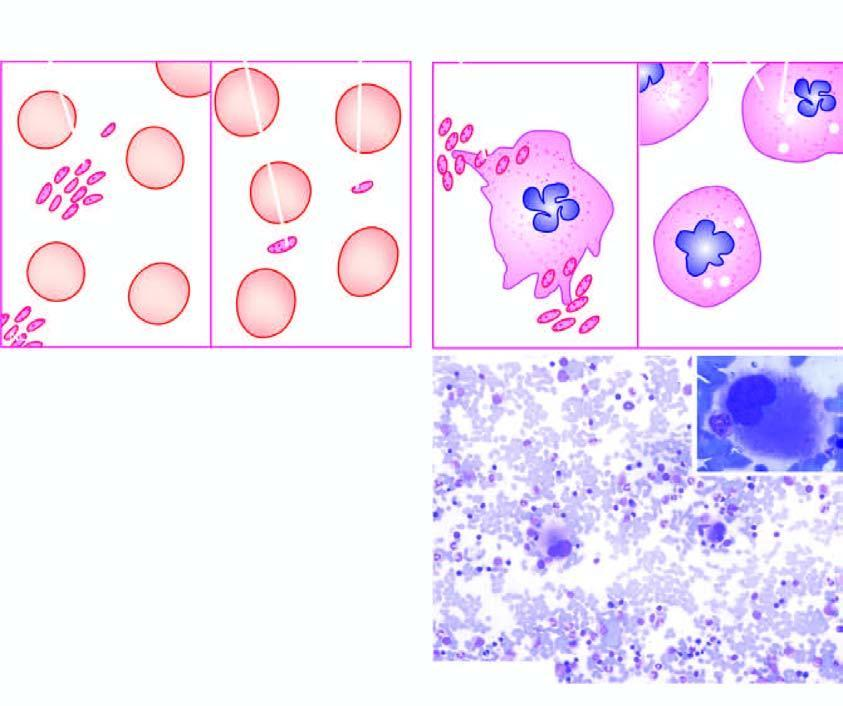s aboratory findings of itp contrasted with those found in a normal individual?
Answer the question using a single word or phrase. Yes 